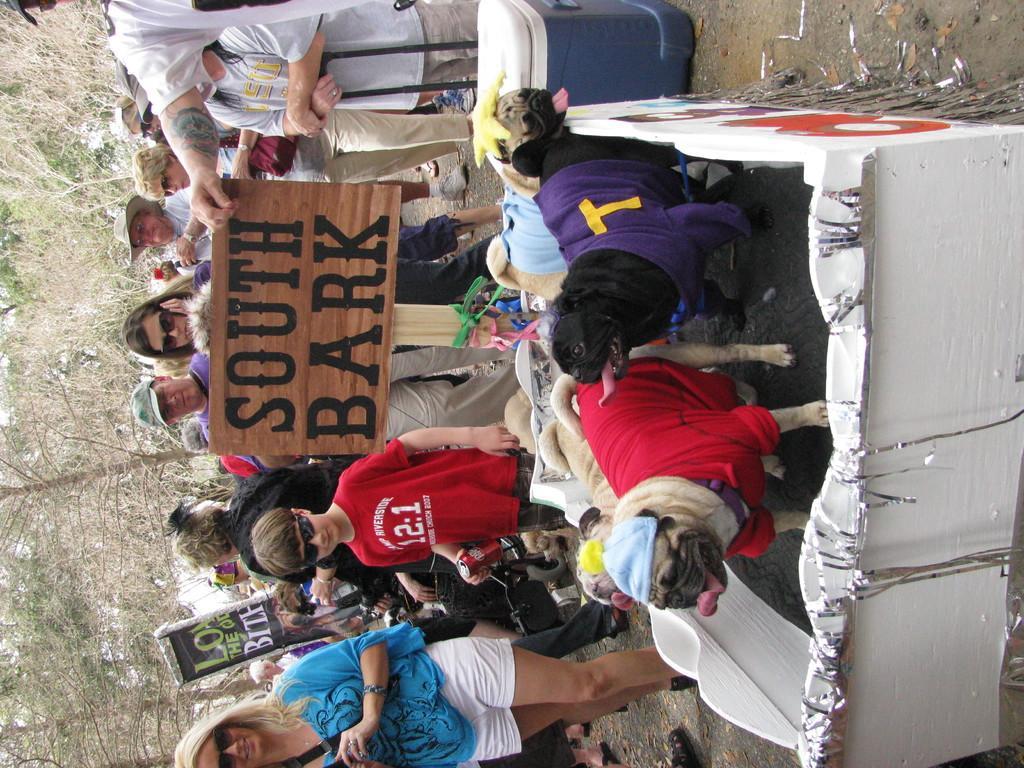Can you describe this image briefly? In the foreground of this image, there are dogs in a wheel cart like an object and there is also a name board with text on it as " SOUTH BARK". In the background, there are persons standing and a suitcase and the trees. 